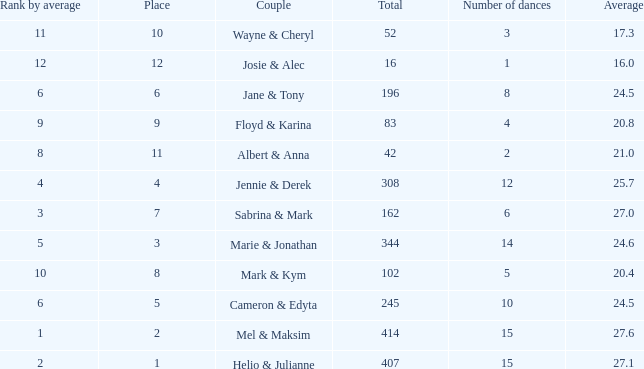What is the average when the rank by average is more than 12? None. 